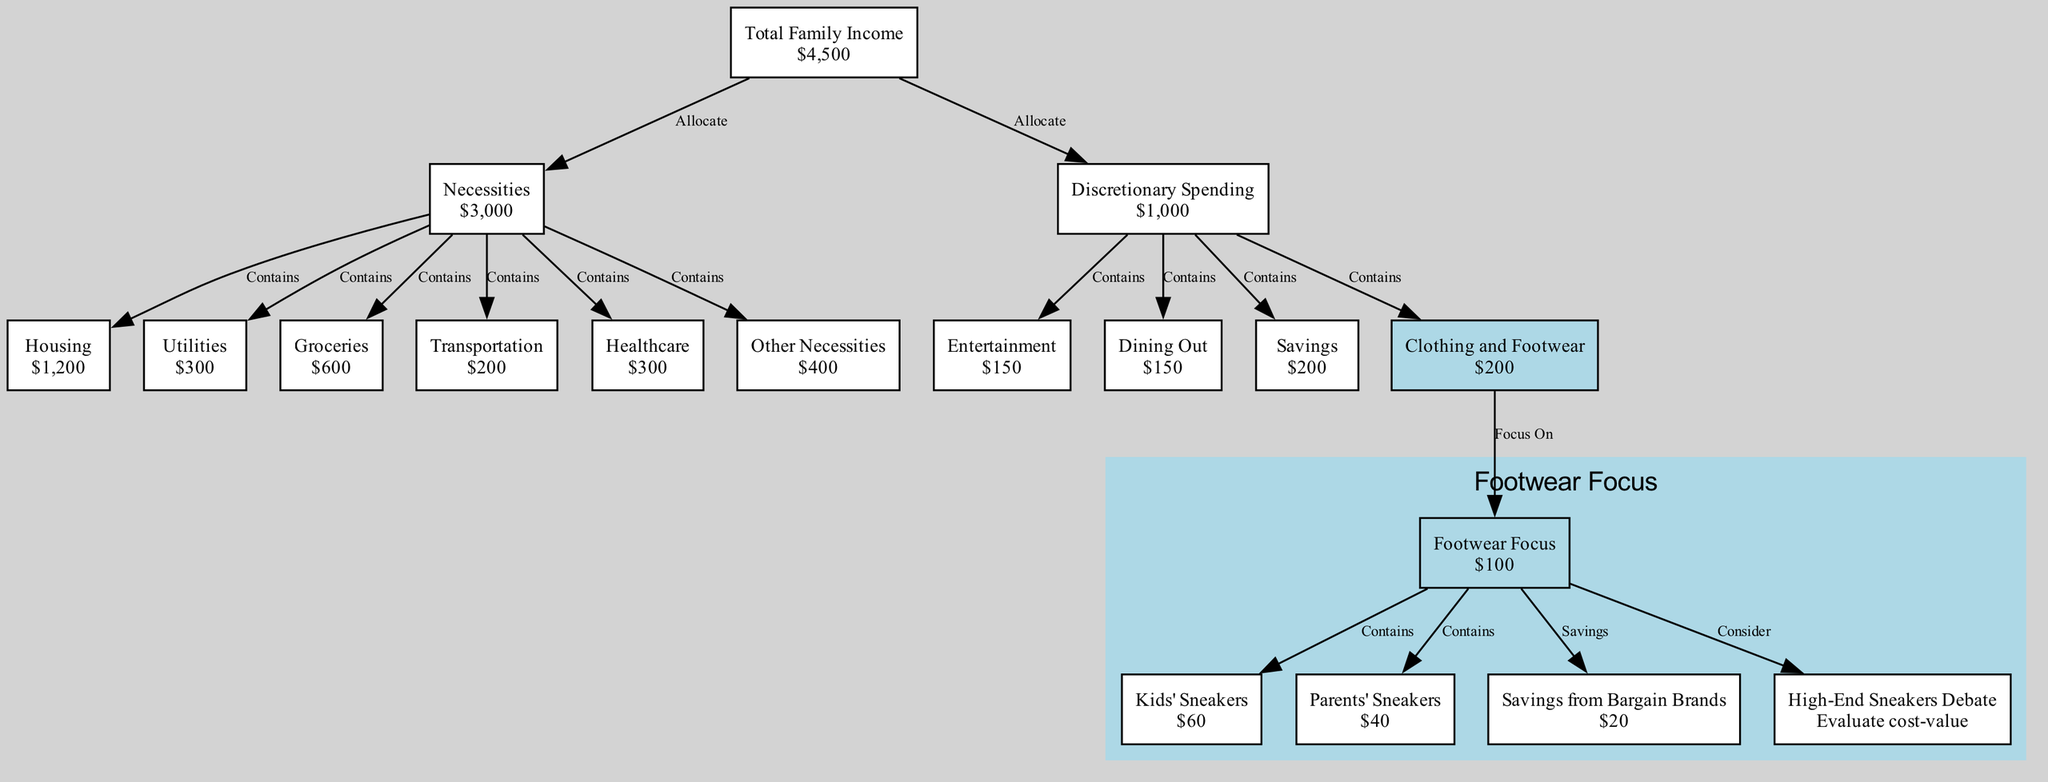What is the total family income? The diagram indicates the "Total Family Income" node, which shows the income value as "$4,500".
Answer: $4,500 How much is allocated to necessities? The node labeled "Necessities" indicates that the amount allocated to necessities is "$3,000".
Answer: $3,000 What is the monthly expense allocated for footwear? The node "Footwear Focus" specifies the expense for footwear as "$100".
Answer: $100 How many nodes are there in the diagram? Counting all the nodes listed in the diagram, there are a total of 18 nodes.
Answer: 18 What is the value of the clothing and footwear budget? The node "Clothing and Footwear" specifies the budget for clothing and footwear as "$200".
Answer: $200 How much is spent on kids' sneakers? The node "Kids' Sneakers" shows the expenditure on kids' sneakers as "$60".
Answer: $60 What percentage of the total income is spent on footwear? To find this, we calculate (Footwear Focus / Total Family Income) * 100 = ($100 / $4,500) * 100 = approximately 2.22%.
Answer: 2.22% What is the savings from bargain brands? The diagram shows the node "Savings from Bargain Brands" with a value of "$20".
Answer: $20 How much is spent on parents' sneakers? The node "Parents' Sneakers" indicates an expense of "$40".
Answer: $40 